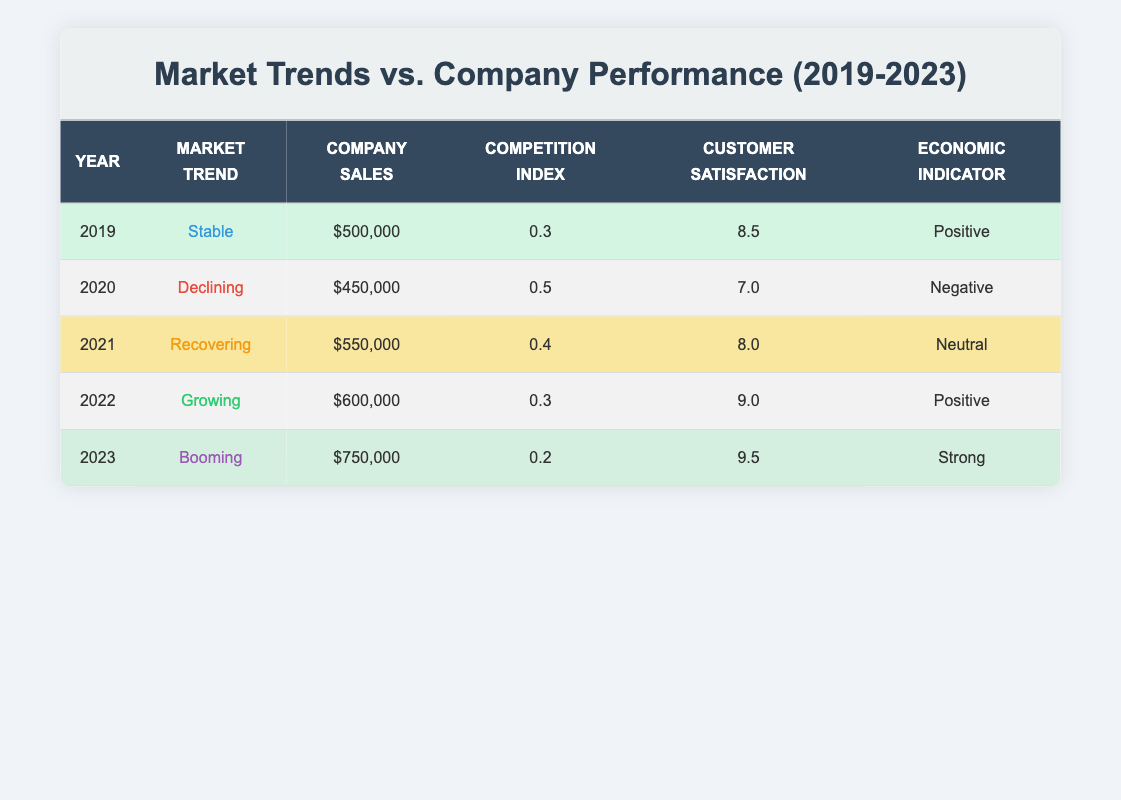What was the company sales value in 2020? The table indicates that in 2020, the company sales were $450,000, which is directly listed in the row corresponding to that year.
Answer: $450,000 Which year had the highest customer satisfaction score? The customer satisfaction scores for each year are as follows: 8.5 in 2019, 7.0 in 2020, 8.0 in 2021, 9.0 in 2022, and 9.5 in 2023. The highest score is 9.5, which corresponds to the year 2023.
Answer: 2023 What is the average company sales over the five years? To find the average, we add the company sales from each year: 500,000 + 450,000 + 550,000 + 600,000 + 750,000 = 2,850,000. Then, we divide by the number of years (5): 2,850,000 / 5 = 570,000.
Answer: $570,000 Did the market trend improve from 2020 to 2021? In 2020, the market trend was "Declining," and in 2021, it had changed to "Recovering," indicating an improvement in market conditions.
Answer: Yes What was the competition index in the year with the highest company sales? The year with the highest company sales is 2023, where the sales reached $750,000. The competition index for that year is 0.2, which can be found in the same row.
Answer: 0.2 How many years had a positive economic indicator? The years with a positive economic indicator are 2019, 2022, and 2023. Counting these years gives us a total of three.
Answer: 3 Is it true that customer satisfaction scores decreased for the years 2019 to 2020? The customer satisfaction scores were 8.5 in 2019 and decreased to 7.0 in 2020, confirming the statement is true.
Answer: True Which market trend was associated with the lowest company sales? The lowest company sales were recorded in 2020, with the market trend being "Declining," as noted in the table.
Answer: Declining What was the difference in company sales between the years 2021 and 2023? The company sales in 2021 were $550,000, while in 2023, they were $750,000. To find the difference, we subtract: 750,000 - 550,000 = 200,000.
Answer: $200,000 